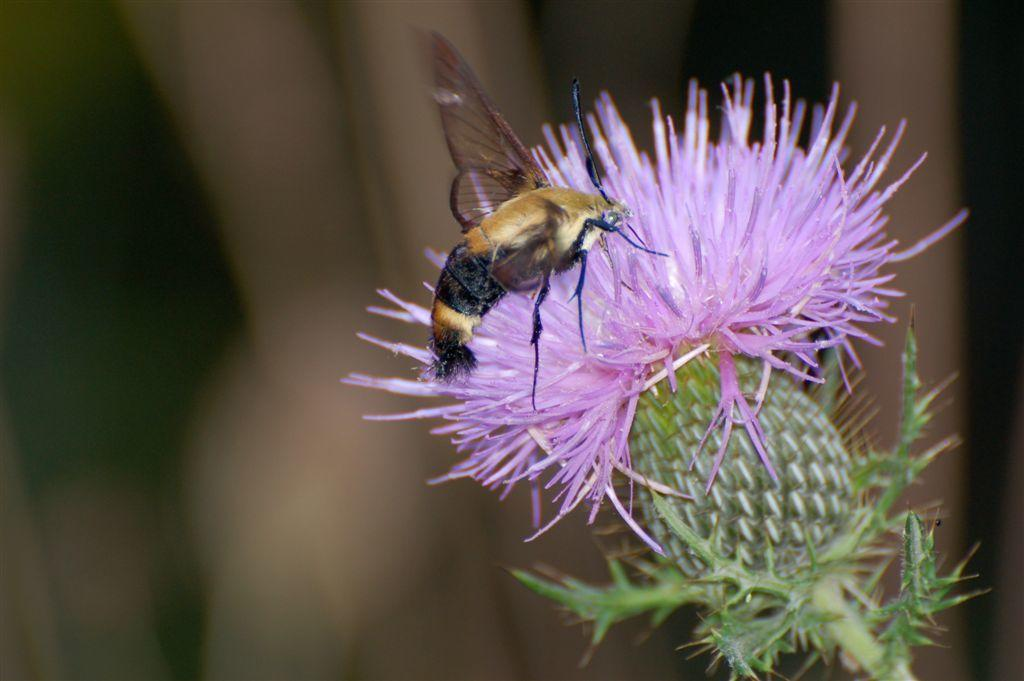What is the main subject of the image? The main subject of the image is an insect on a flower. Can you describe the flower in the image? There is a green stem associated with the flower. What can be observed about the background of the image? The background of the image is blurred. What type of fowl can be seen in the image? There is no fowl present in the image; it features an insect on a flower. Is there a prison visible in the image? There is no prison present in the image. 